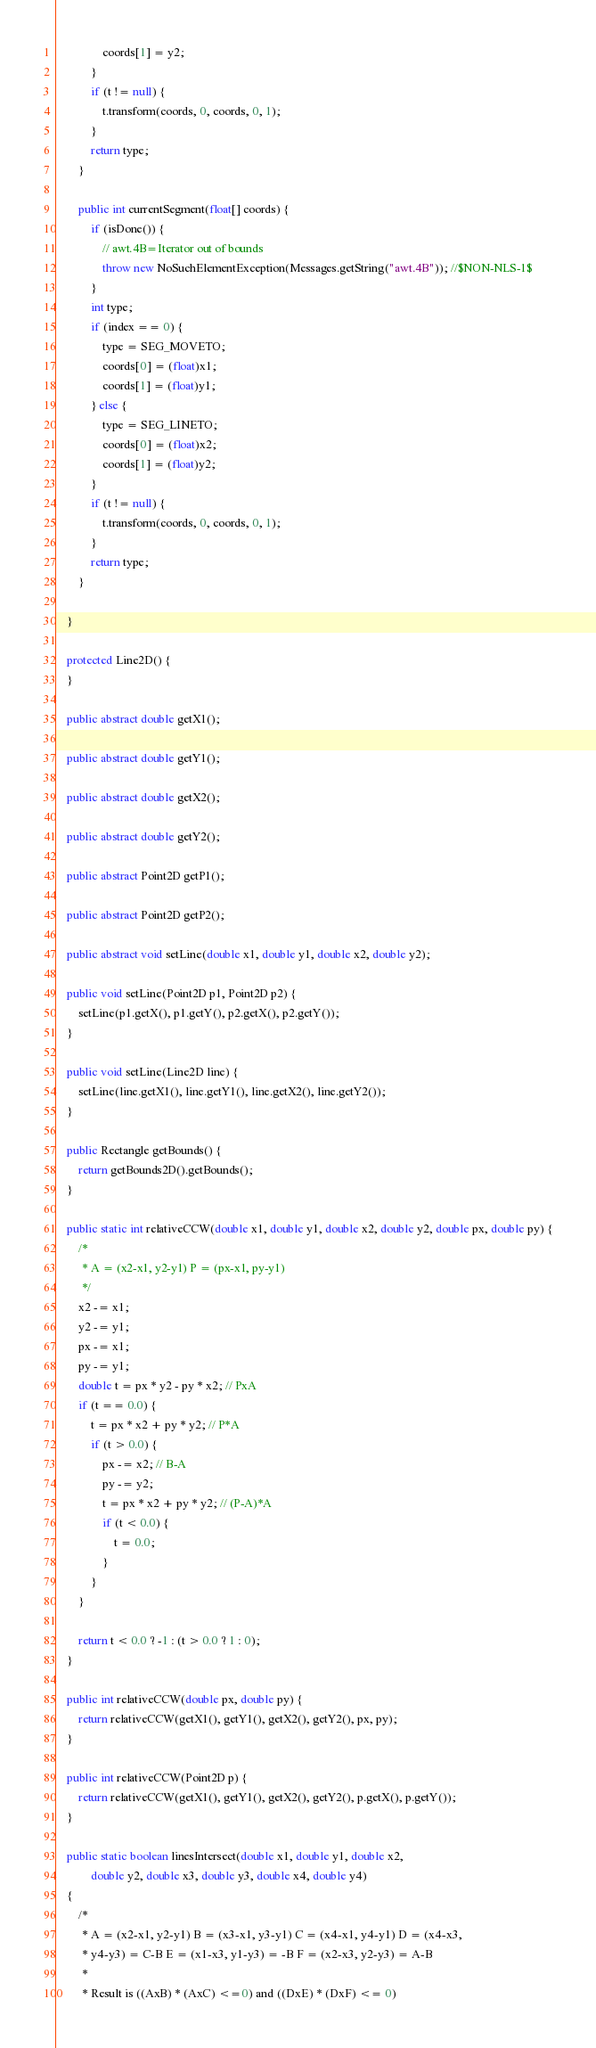<code> <loc_0><loc_0><loc_500><loc_500><_Java_>                coords[1] = y2;
            }
            if (t != null) {
                t.transform(coords, 0, coords, 0, 1);
            }
            return type;
        }

        public int currentSegment(float[] coords) {
            if (isDone()) {
                // awt.4B=Iterator out of bounds
                throw new NoSuchElementException(Messages.getString("awt.4B")); //$NON-NLS-1$
            }
            int type;
            if (index == 0) {
                type = SEG_MOVETO;
                coords[0] = (float)x1;
                coords[1] = (float)y1;
            } else {
                type = SEG_LINETO;
                coords[0] = (float)x2;
                coords[1] = (float)y2;
            }
            if (t != null) {
                t.transform(coords, 0, coords, 0, 1);
            }
            return type;
        }

    }

    protected Line2D() {
    }

    public abstract double getX1();

    public abstract double getY1();

    public abstract double getX2();

    public abstract double getY2();

    public abstract Point2D getP1();

    public abstract Point2D getP2();

    public abstract void setLine(double x1, double y1, double x2, double y2);

    public void setLine(Point2D p1, Point2D p2) {
        setLine(p1.getX(), p1.getY(), p2.getX(), p2.getY());
    }

    public void setLine(Line2D line) {
        setLine(line.getX1(), line.getY1(), line.getX2(), line.getY2());
    }

    public Rectangle getBounds() {
        return getBounds2D().getBounds();
    }

    public static int relativeCCW(double x1, double y1, double x2, double y2, double px, double py) {
        /*
         * A = (x2-x1, y2-y1) P = (px-x1, py-y1)
         */
        x2 -= x1;
        y2 -= y1;
        px -= x1;
        py -= y1;
        double t = px * y2 - py * x2; // PxA
        if (t == 0.0) {
            t = px * x2 + py * y2; // P*A
            if (t > 0.0) {
                px -= x2; // B-A
                py -= y2;
                t = px * x2 + py * y2; // (P-A)*A
                if (t < 0.0) {
                    t = 0.0;
                }
            }
        }

        return t < 0.0 ? -1 : (t > 0.0 ? 1 : 0);
    }

    public int relativeCCW(double px, double py) {
        return relativeCCW(getX1(), getY1(), getX2(), getY2(), px, py);
    }

    public int relativeCCW(Point2D p) {
        return relativeCCW(getX1(), getY1(), getX2(), getY2(), p.getX(), p.getY());
    }

    public static boolean linesIntersect(double x1, double y1, double x2,
            double y2, double x3, double y3, double x4, double y4)
    {
        /*
         * A = (x2-x1, y2-y1) B = (x3-x1, y3-y1) C = (x4-x1, y4-y1) D = (x4-x3,
         * y4-y3) = C-B E = (x1-x3, y1-y3) = -B F = (x2-x3, y2-y3) = A-B
         *
         * Result is ((AxB) * (AxC) <=0) and ((DxE) * (DxF) <= 0)</code> 